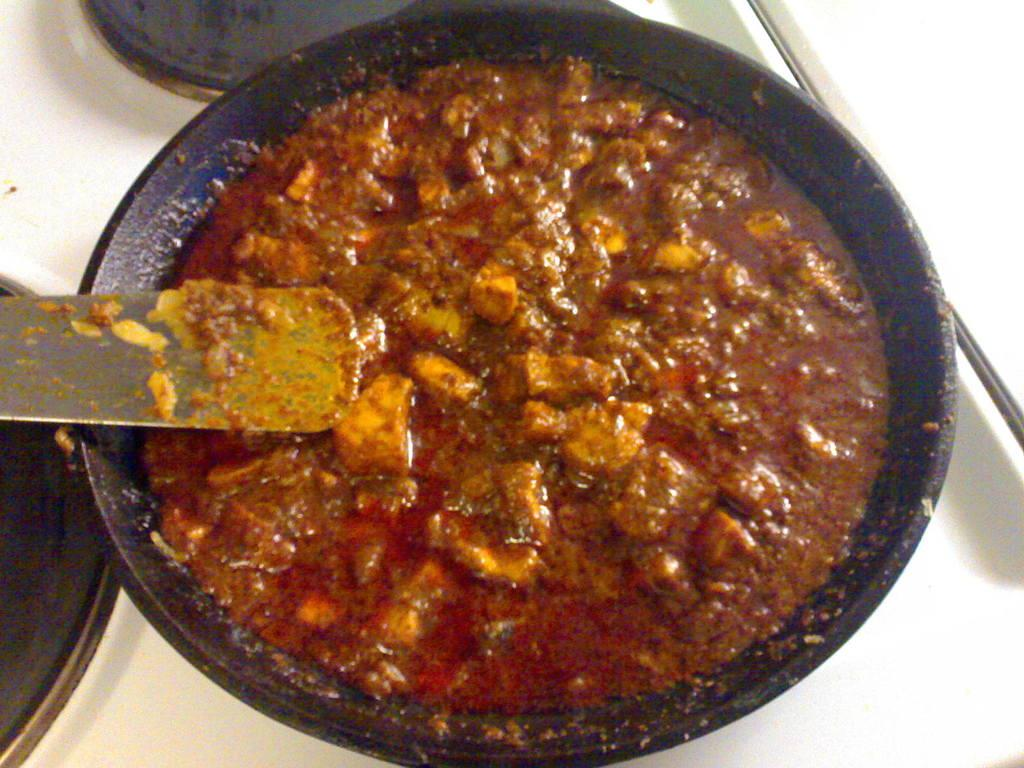What is the main object in the image? There is a cooking pan in the image. What is inside the cooking pan? There is a food item in the cooking pan. What utensil is visible in the image? There is a spatula in the image. What can be seen in the background of the image? There is a stove in the background of the image. How much money can be seen on the moon in the image? There is no moon or money present in the image. 